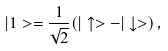<formula> <loc_0><loc_0><loc_500><loc_500>| 1 > = \frac { 1 } { \sqrt { 2 } } ( | \uparrow > - | \downarrow > ) \, ,</formula> 